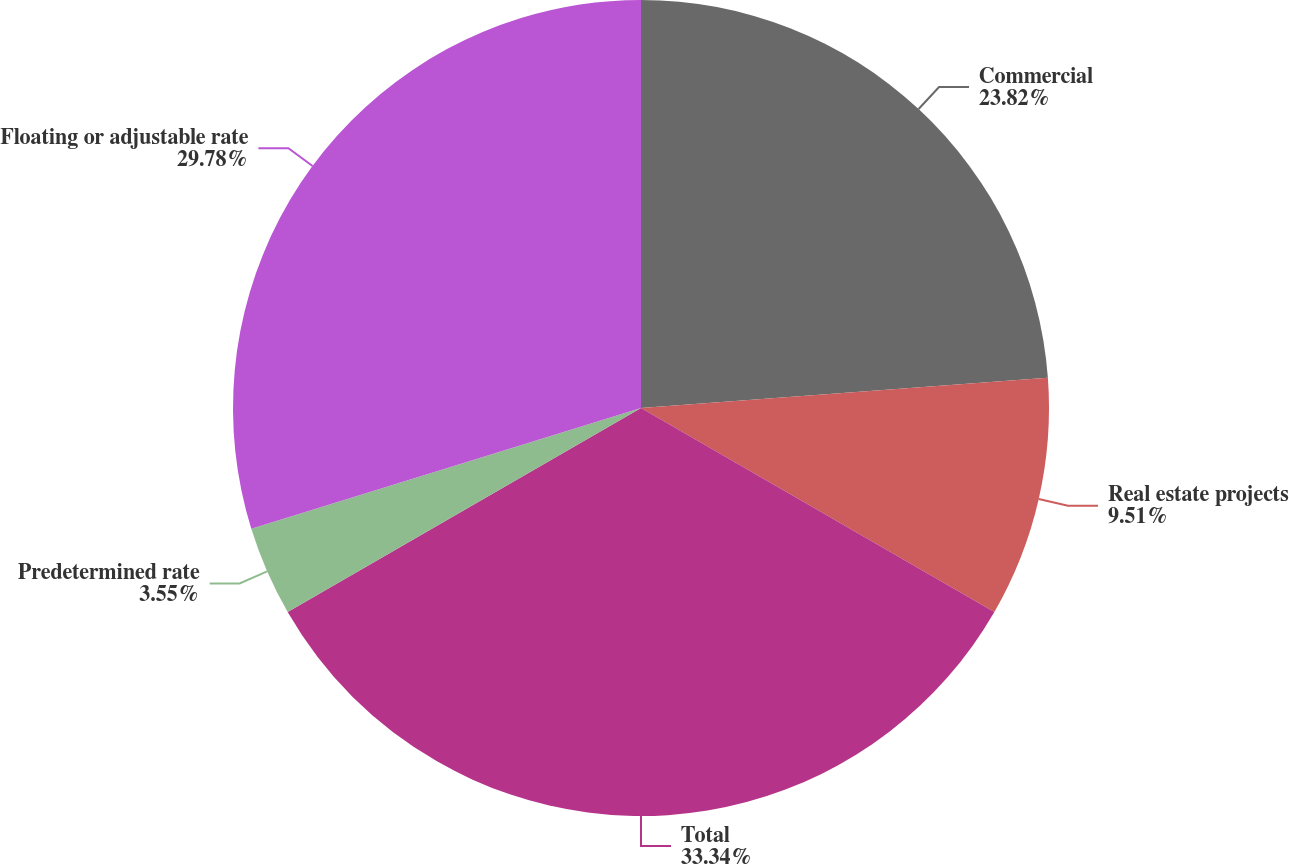Convert chart. <chart><loc_0><loc_0><loc_500><loc_500><pie_chart><fcel>Commercial<fcel>Real estate projects<fcel>Total<fcel>Predetermined rate<fcel>Floating or adjustable rate<nl><fcel>23.82%<fcel>9.51%<fcel>33.33%<fcel>3.55%<fcel>29.78%<nl></chart> 